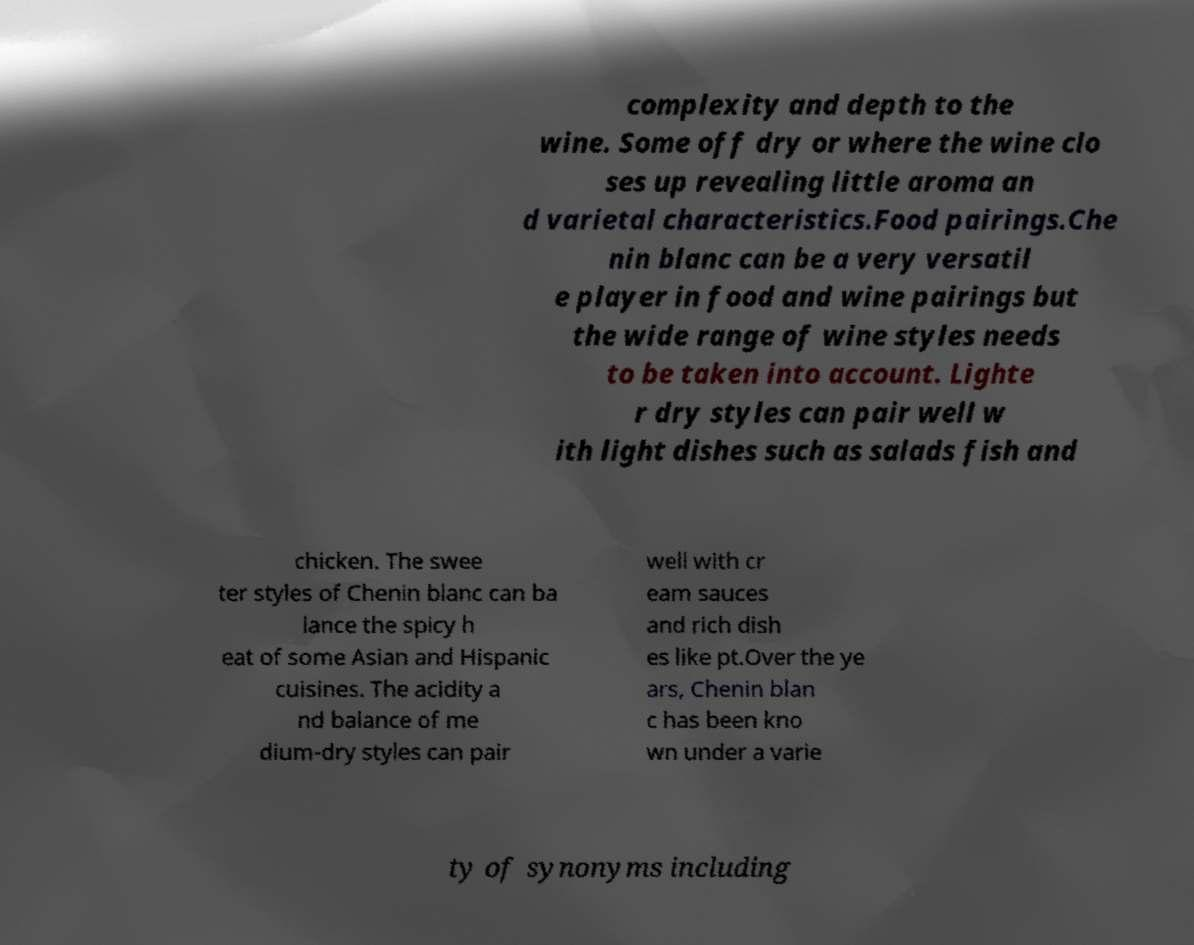Can you read and provide the text displayed in the image?This photo seems to have some interesting text. Can you extract and type it out for me? complexity and depth to the wine. Some off dry or where the wine clo ses up revealing little aroma an d varietal characteristics.Food pairings.Che nin blanc can be a very versatil e player in food and wine pairings but the wide range of wine styles needs to be taken into account. Lighte r dry styles can pair well w ith light dishes such as salads fish and chicken. The swee ter styles of Chenin blanc can ba lance the spicy h eat of some Asian and Hispanic cuisines. The acidity a nd balance of me dium-dry styles can pair well with cr eam sauces and rich dish es like pt.Over the ye ars, Chenin blan c has been kno wn under a varie ty of synonyms including 